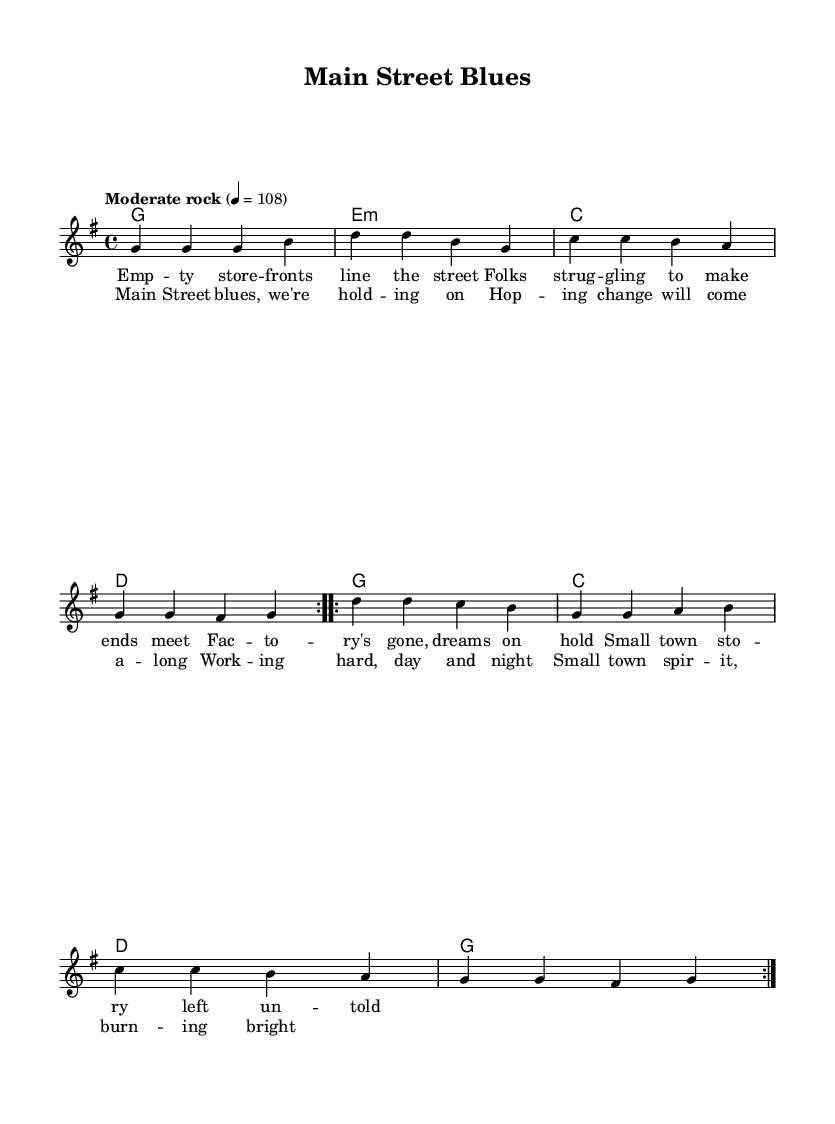What is the key signature of this music? The key signature of the piece is G major, which has one sharp (F#). This can be determined by looking at the key signature indicator at the beginning of the music sheet, right after the clef.
Answer: G major What is the time signature of this music? The time signature is 4/4, indicated on the second staff of the music. This means there are four beats in each measure, and the quarter note gets one beat.
Answer: 4/4 What is the indicated tempo of this music? The tempo indicated at the beginning of the piece is "Moderate rock" with a tempo marking of 108 beats per minute. This suggests a moderate, steady pace for the performance.
Answer: 108 How many measures are repeated in the melody section? The melody section has two distinct parts, each of which is repeated twice, indicated by the repeat signs. Thus, four measures are involved in the repetition.
Answer: 4 What type of chord is used in the second measure of the harmonies? The second measure of the harmonies contains an E minor chord, as indicated by the "e:m" label in the chord line. This clearly shows the tonality of the chord being played.
Answer: E minor How do the lyrics reflect the theme of economic struggle? The lyrics reference "empty store fronts" and "folks struggling to make ends meet," directly addressing the challenges faced by small-town residents dealing with economic hardship. The words capture the essence of local struggles.
Answer: Economic hardship 